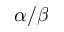<formula> <loc_0><loc_0><loc_500><loc_500>\alpha / \beta</formula> 